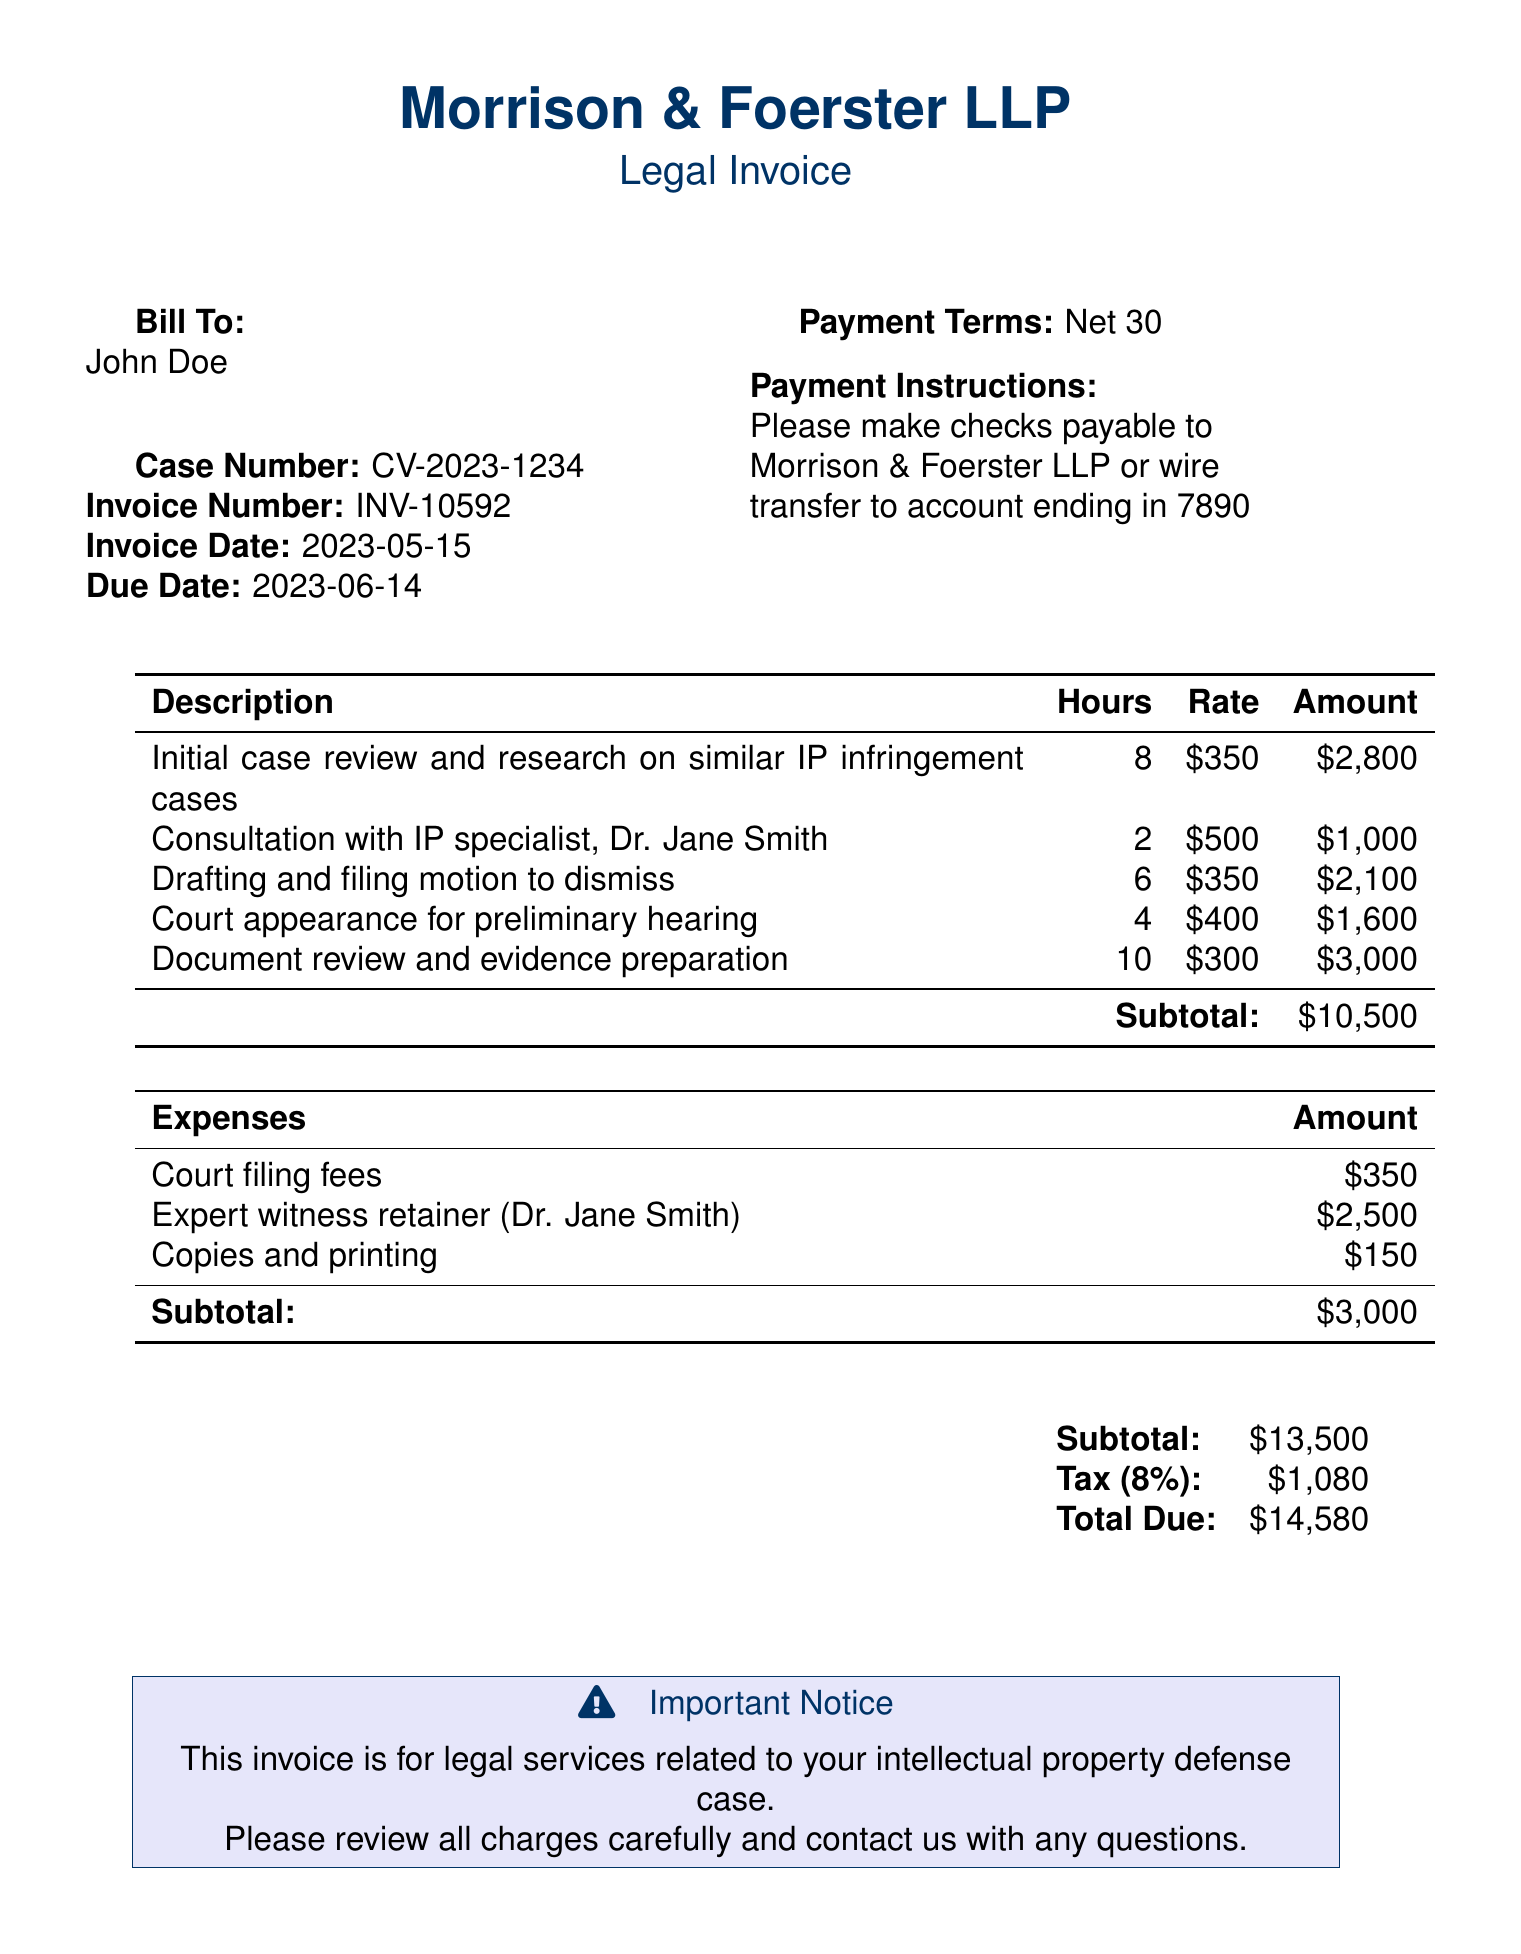what is the case number? The case number is indicated in the header section of the document, which is CV-2023-1234.
Answer: CV-2023-1234 who is the attorney consulted? The document specifies the consultation was with Dr. Jane Smith, who is identified as an IP specialist.
Answer: Dr. Jane Smith what is the total amount due? The total amount due is listed in the summary section at the bottom of the invoice, which includes subtotal and tax.
Answer: $14,580 how many hours were billed for document review? The number of hours billed for document review and evidence preparation is provided in the itemized charges section.
Answer: 10 what is the charge for the court appearance? The court appearance for the preliminary hearing is itemized with a specific amount in the charges section.
Answer: $1,600 what percentage tax was applied to the invoice? The tax percentage is stated in the summary section of the invoice, which is 8%.
Answer: 8% what is the invoice date? The invoice date is mentioned in the header, specifying when the bill was issued.
Answer: 2023-05-15 how much was charged for the expert witness retainer? The document includes a specific entry for expert witness retainer fees in the expenses section.
Answer: $2,500 what is the payment term specified in the document? Payment terms are outlined clearly in the document, detailing the timeframe for payments.
Answer: Net 30 